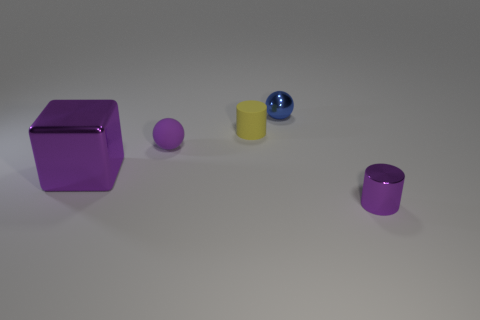Can you infer any possible symbolic meanings that these objects might represent if this were a piece of conceptual art? If we consider this arrangement as a piece of conceptual art, several interpretations become plausible. The cube could symbolize structure and rationality, while the sphere might represent wholeness and unity. The cylinder's upright position could denote growth or ascension. The smaller sizes of the purple object potentially indicate a lesser degree of the attributes they represent, or perhaps a developing stage. The contrasting colors might suggest duality or the presence of opposing forces in balance. The interpretation of such an exhibit often lies in the viewer's perception and the context provided by the artist. 